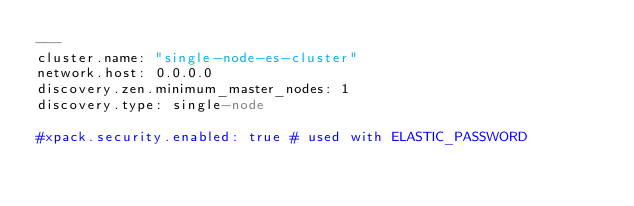<code> <loc_0><loc_0><loc_500><loc_500><_YAML_>---
cluster.name: "single-node-es-cluster"
network.host: 0.0.0.0
discovery.zen.minimum_master_nodes: 1
discovery.type: single-node

#xpack.security.enabled: true # used with ELASTIC_PASSWORD
</code> 